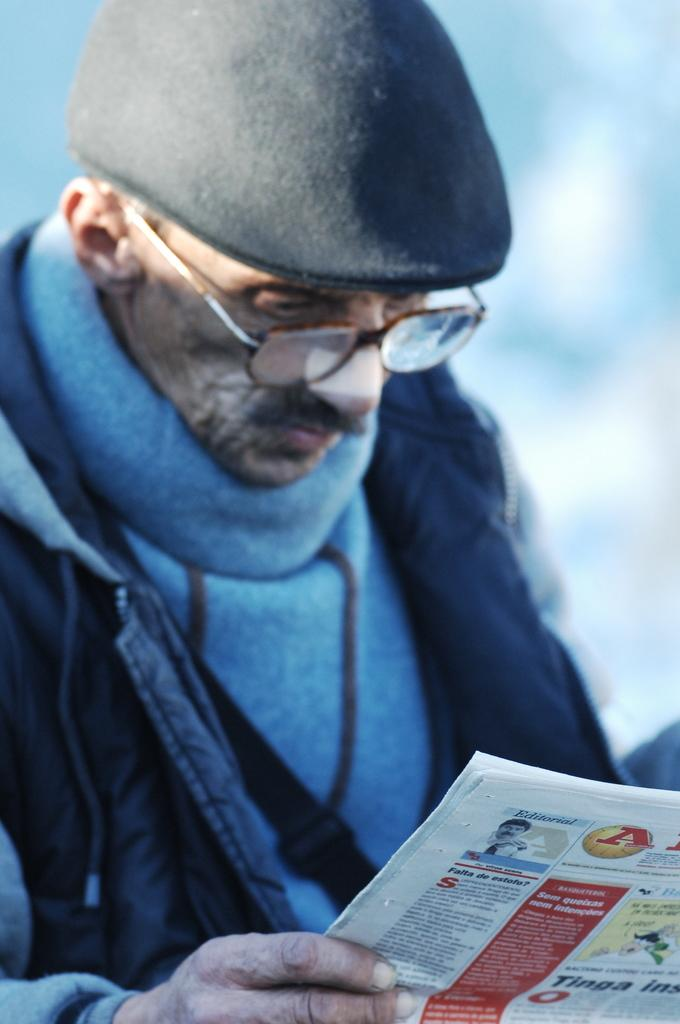What can be seen in the image? There is a person in the image. Can you describe the person's clothing? The person is wearing a blue and black colored jacket and a black colored hat. What accessory is the person wearing? The person is wearing spectacles. What is the person holding in the image? The person is holding a newspaper in his hands. How would you describe the background of the image? The background of the image is blurry. What type of animal can be seen in the image? There is no animal present in the image; it features a person wearing a jacket, hat, and spectacles, holding a newspaper, and standing in front of a blurry background. 